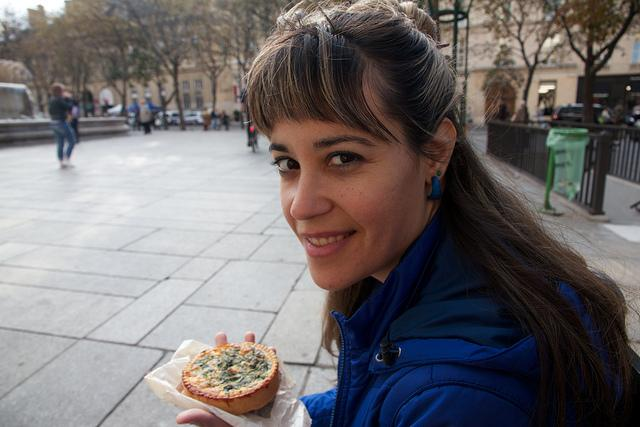What is matching the color of her jacket? earrings 